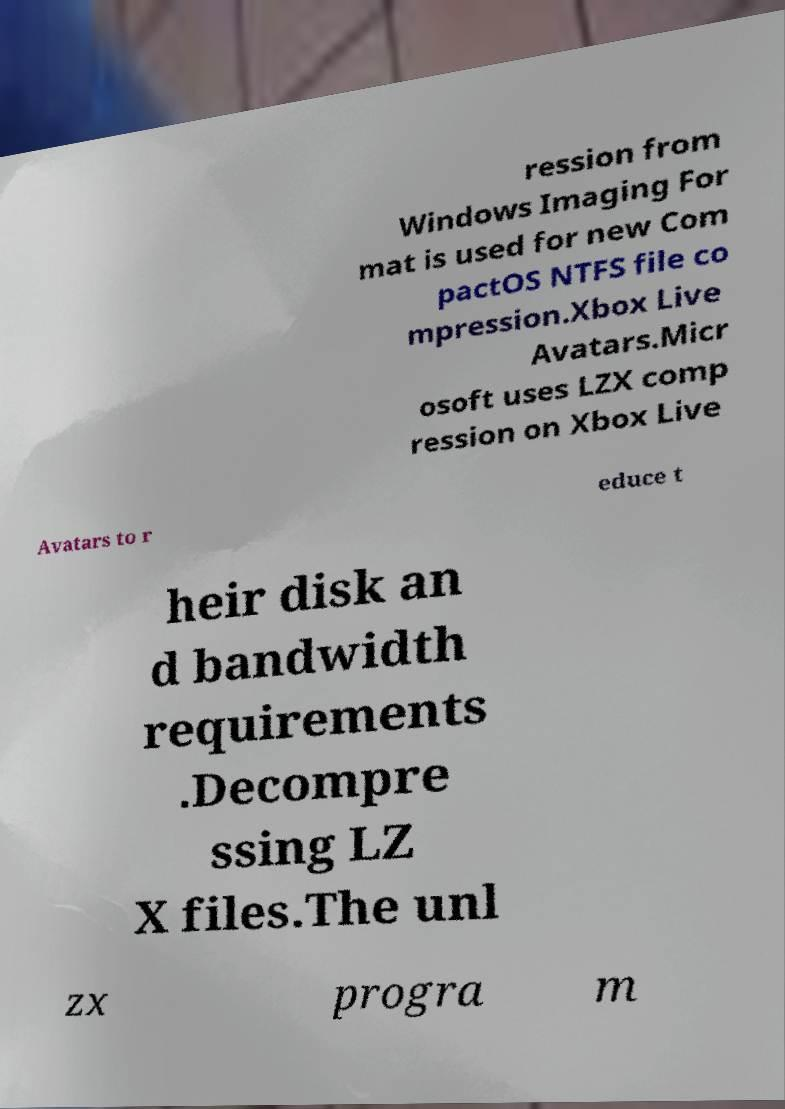Please read and relay the text visible in this image. What does it say? ression from Windows Imaging For mat is used for new Com pactOS NTFS file co mpression.Xbox Live Avatars.Micr osoft uses LZX comp ression on Xbox Live Avatars to r educe t heir disk an d bandwidth requirements .Decompre ssing LZ X files.The unl zx progra m 